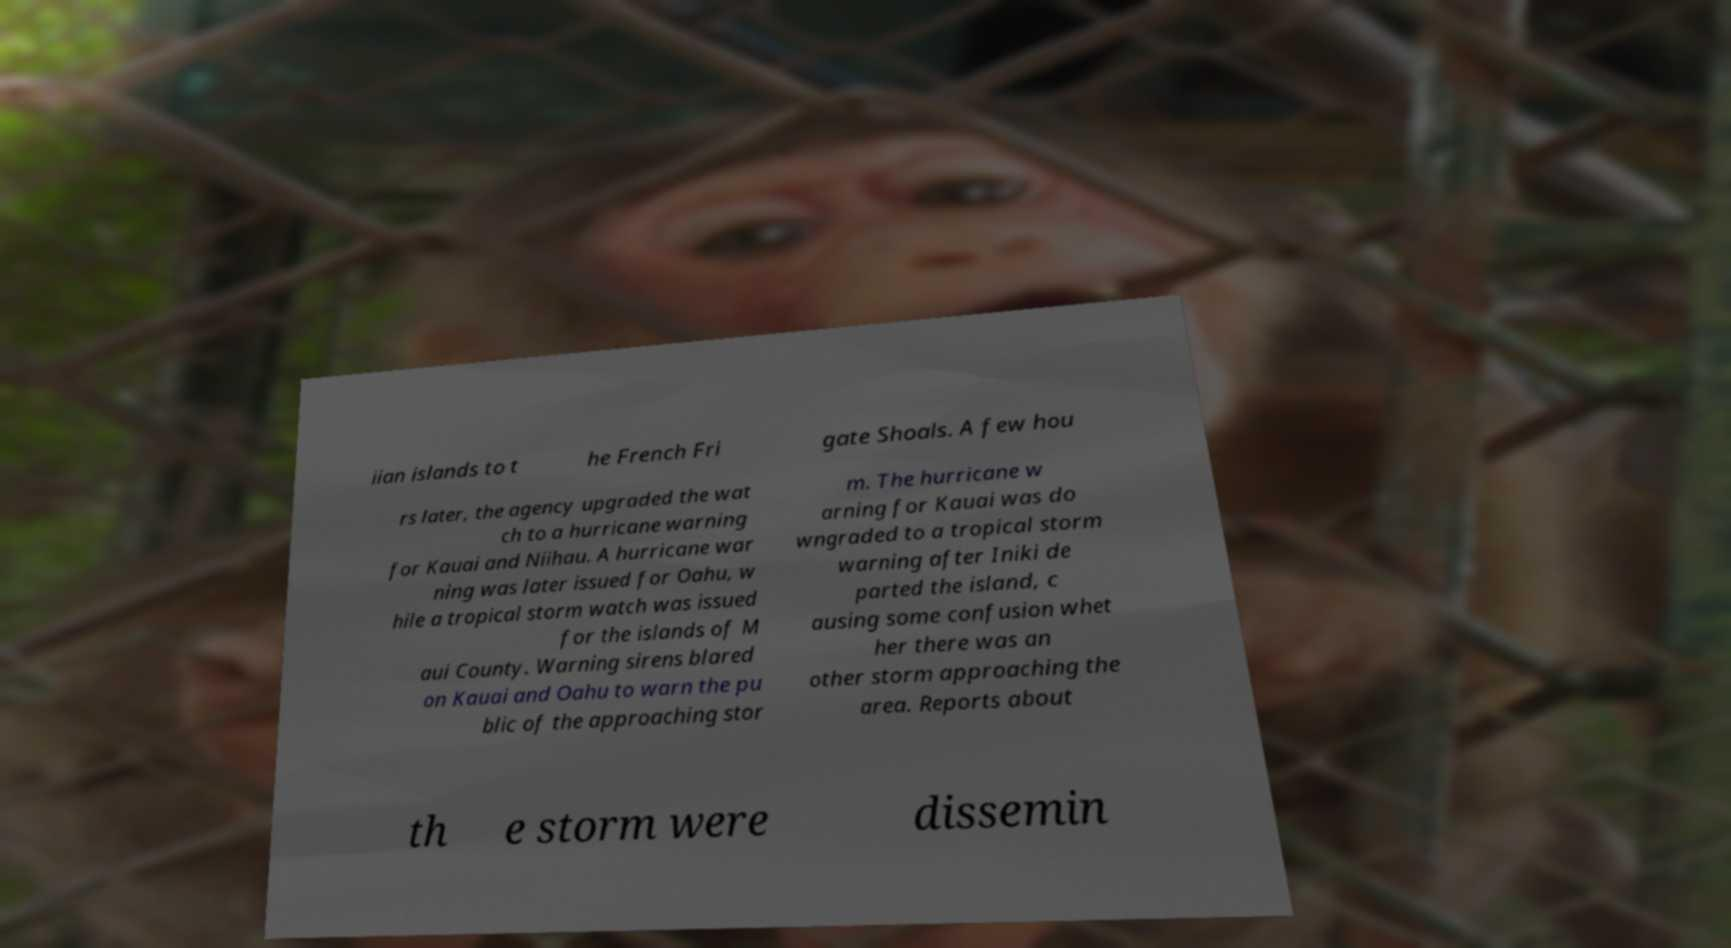Please identify and transcribe the text found in this image. iian islands to t he French Fri gate Shoals. A few hou rs later, the agency upgraded the wat ch to a hurricane warning for Kauai and Niihau. A hurricane war ning was later issued for Oahu, w hile a tropical storm watch was issued for the islands of M aui County. Warning sirens blared on Kauai and Oahu to warn the pu blic of the approaching stor m. The hurricane w arning for Kauai was do wngraded to a tropical storm warning after Iniki de parted the island, c ausing some confusion whet her there was an other storm approaching the area. Reports about th e storm were dissemin 